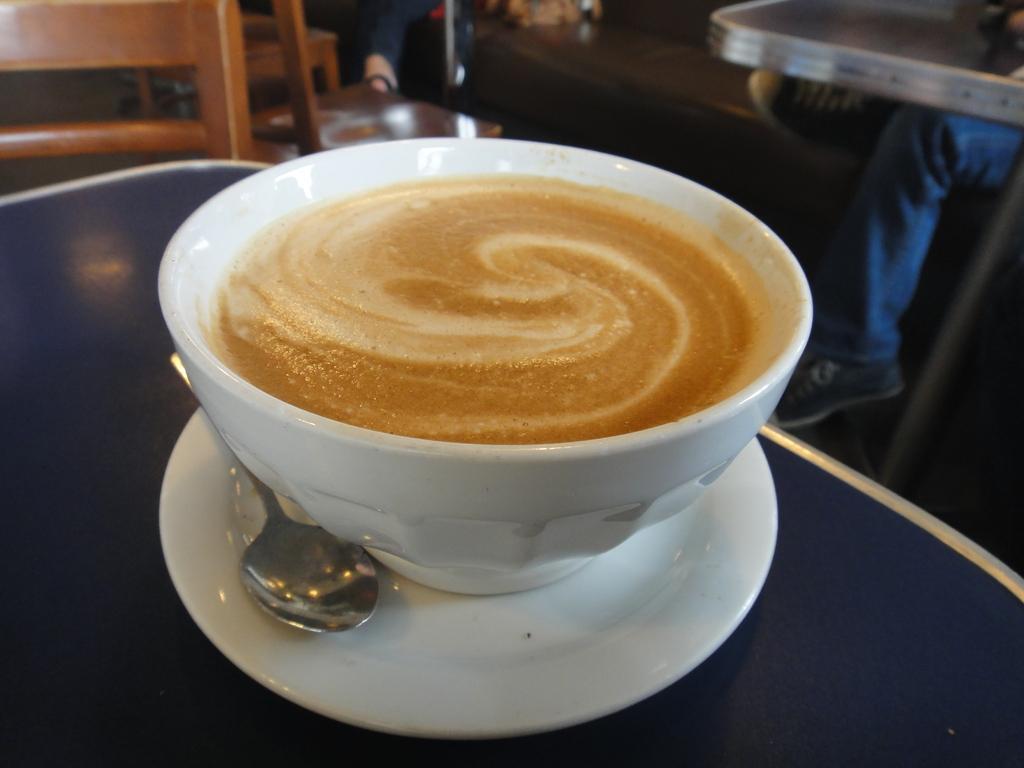How would you summarize this image in a sentence or two? In this picture there is a cup filled with coffee with a spoon and a saucer kept on the table. 